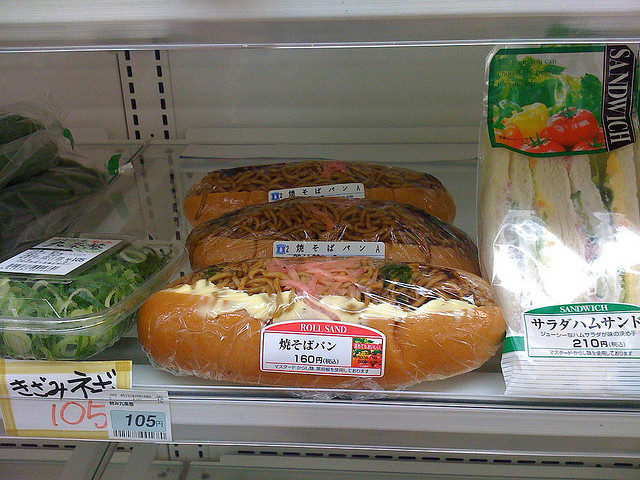Extract all visible text content from this image. SANDWICH SANDWICH 210 ROLL SAND 160 105F 105 